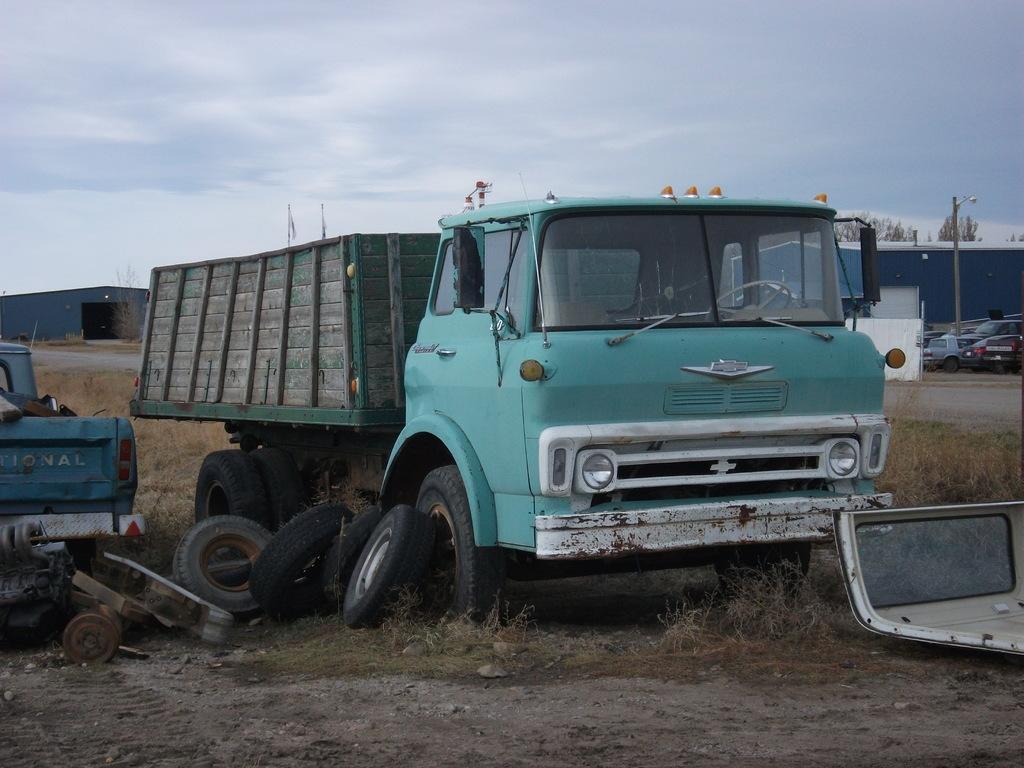Can you describe this image briefly? In this picture we can see vehicles, tyres and some objects on the ground. Behind the vehicles, there are sheds, trees and grass. On the right side of the image, there is a pole and a wall. At the top of the image, there is the sky. 